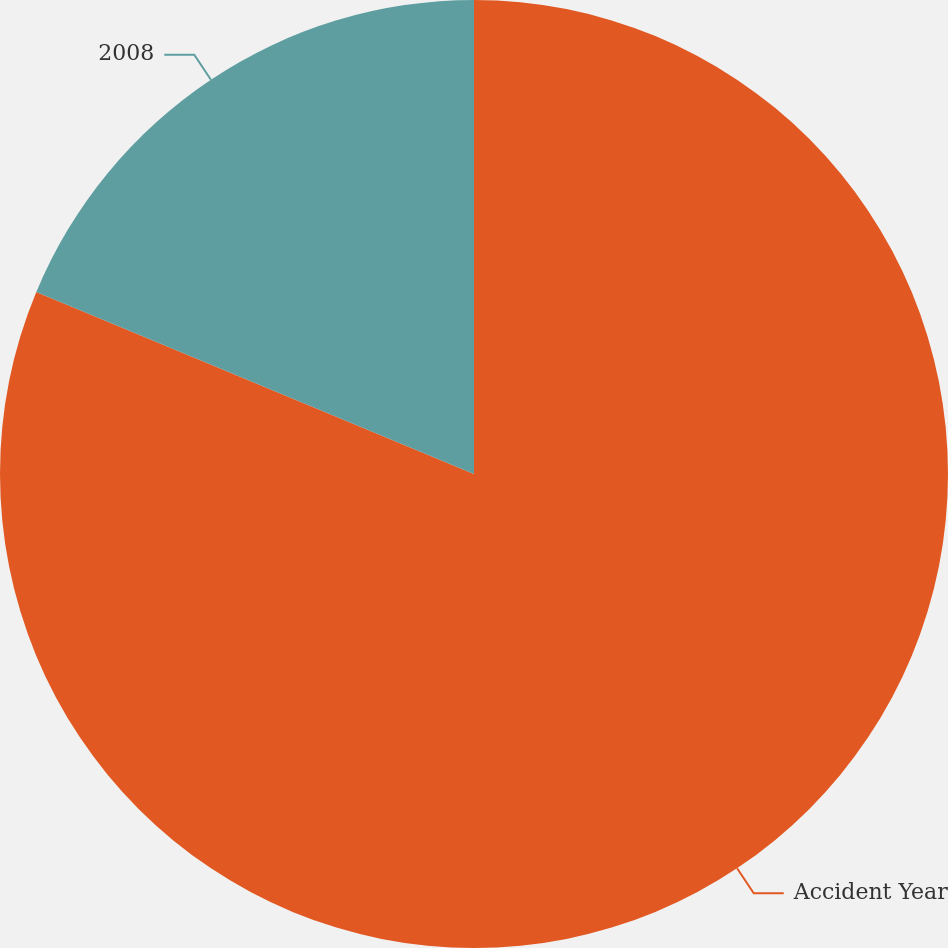Convert chart. <chart><loc_0><loc_0><loc_500><loc_500><pie_chart><fcel>Accident Year<fcel>2008<nl><fcel>81.27%<fcel>18.73%<nl></chart> 